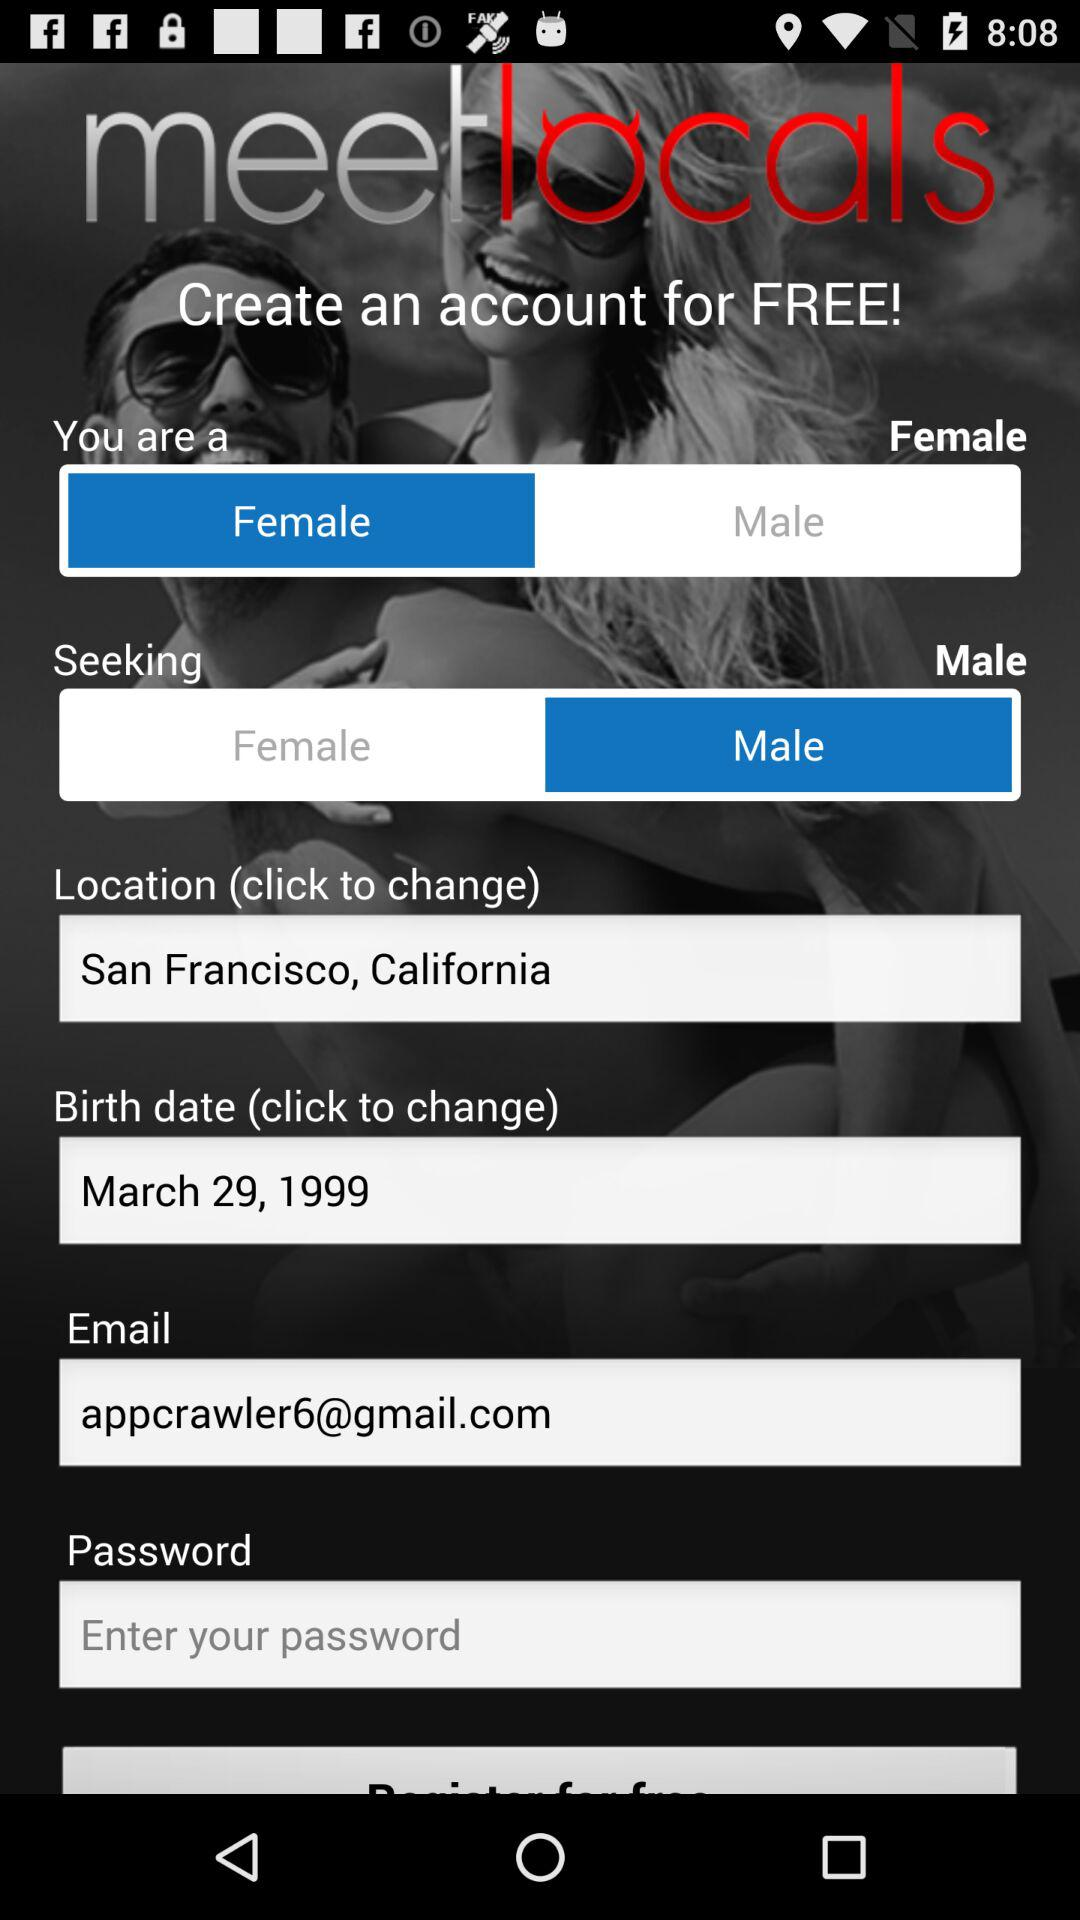How much does it cost to create an account? Creating an account is free. 